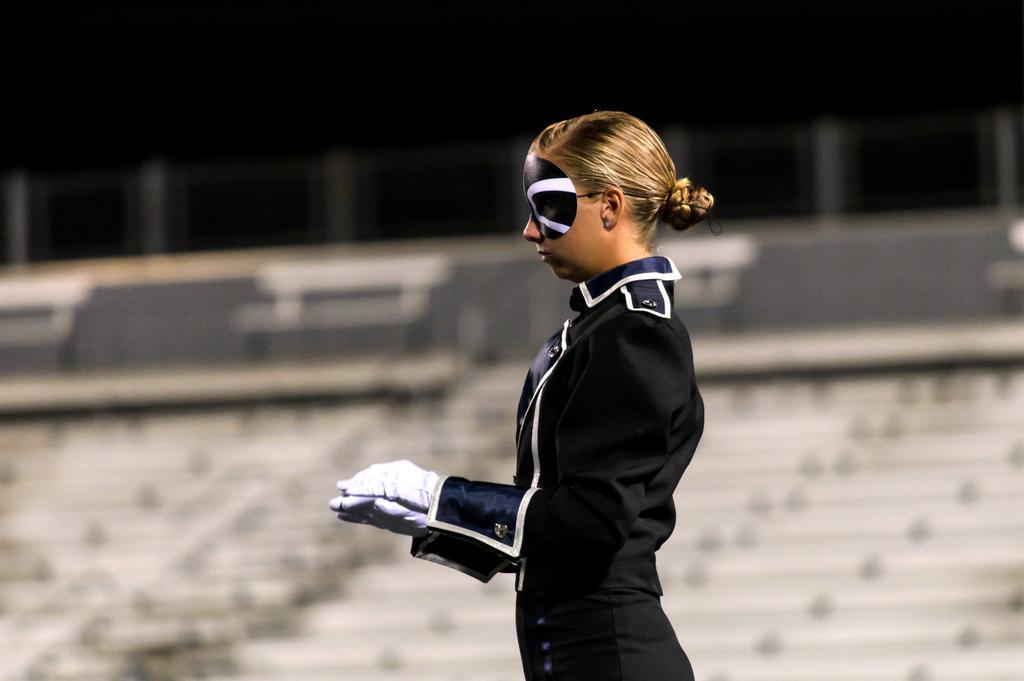Describe this image in one or two sentences. This image is taken outdoors. In this image the background is blurry and we can see there are a few objects. They seem like empty benches and stairs. In the middle of the image a woman is standing and she is with a blindfold. 